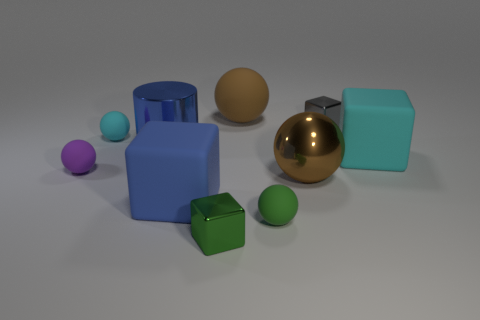Can you describe the arrangement and colors of the objects in this image? Certainly! There are several objects with a variety of colors and shapes systematically arranged. On the left side, there is a vibrant purple sphere and a small cyan cylinder atop a larger blue cylinder. In the center, a golden sphere sits closely to a green cube. On the right, a small green sphere pairs next to a large cyan square block. 